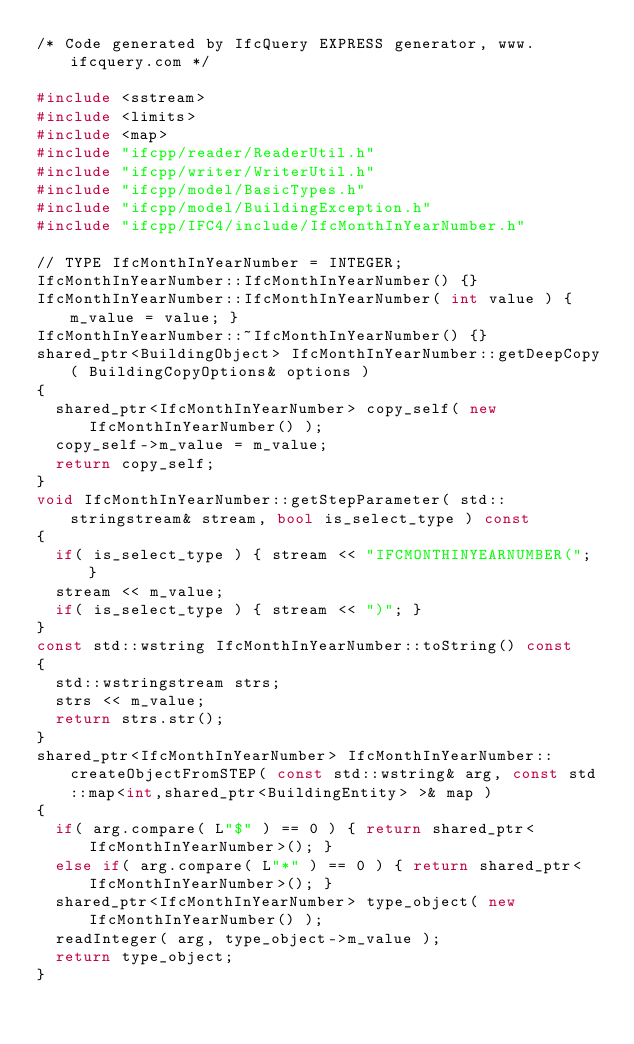Convert code to text. <code><loc_0><loc_0><loc_500><loc_500><_C++_>/* Code generated by IfcQuery EXPRESS generator, www.ifcquery.com */

#include <sstream>
#include <limits>
#include <map>
#include "ifcpp/reader/ReaderUtil.h"
#include "ifcpp/writer/WriterUtil.h"
#include "ifcpp/model/BasicTypes.h"
#include "ifcpp/model/BuildingException.h"
#include "ifcpp/IFC4/include/IfcMonthInYearNumber.h"

// TYPE IfcMonthInYearNumber = INTEGER;
IfcMonthInYearNumber::IfcMonthInYearNumber() {}
IfcMonthInYearNumber::IfcMonthInYearNumber( int value ) { m_value = value; }
IfcMonthInYearNumber::~IfcMonthInYearNumber() {}
shared_ptr<BuildingObject> IfcMonthInYearNumber::getDeepCopy( BuildingCopyOptions& options )
{
	shared_ptr<IfcMonthInYearNumber> copy_self( new IfcMonthInYearNumber() );
	copy_self->m_value = m_value;
	return copy_self;
}
void IfcMonthInYearNumber::getStepParameter( std::stringstream& stream, bool is_select_type ) const
{
	if( is_select_type ) { stream << "IFCMONTHINYEARNUMBER("; }
	stream << m_value;
	if( is_select_type ) { stream << ")"; }
}
const std::wstring IfcMonthInYearNumber::toString() const
{
	std::wstringstream strs;
	strs << m_value;
	return strs.str();
}
shared_ptr<IfcMonthInYearNumber> IfcMonthInYearNumber::createObjectFromSTEP( const std::wstring& arg, const std::map<int,shared_ptr<BuildingEntity> >& map )
{
	if( arg.compare( L"$" ) == 0 ) { return shared_ptr<IfcMonthInYearNumber>(); }
	else if( arg.compare( L"*" ) == 0 ) { return shared_ptr<IfcMonthInYearNumber>(); }
	shared_ptr<IfcMonthInYearNumber> type_object( new IfcMonthInYearNumber() );
	readInteger( arg, type_object->m_value );
	return type_object;
}
</code> 